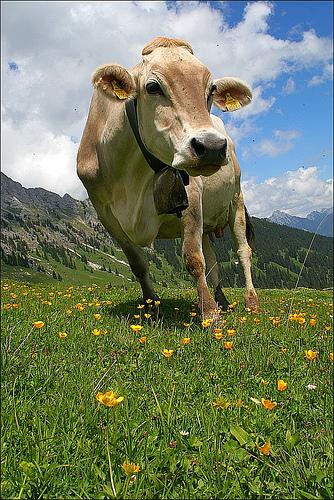How many flowers are in the field?
Be succinct. Many. What is in the cow's ears?
Write a very short answer. Tags. What season does it appear to be?
Answer briefly. Summer. 